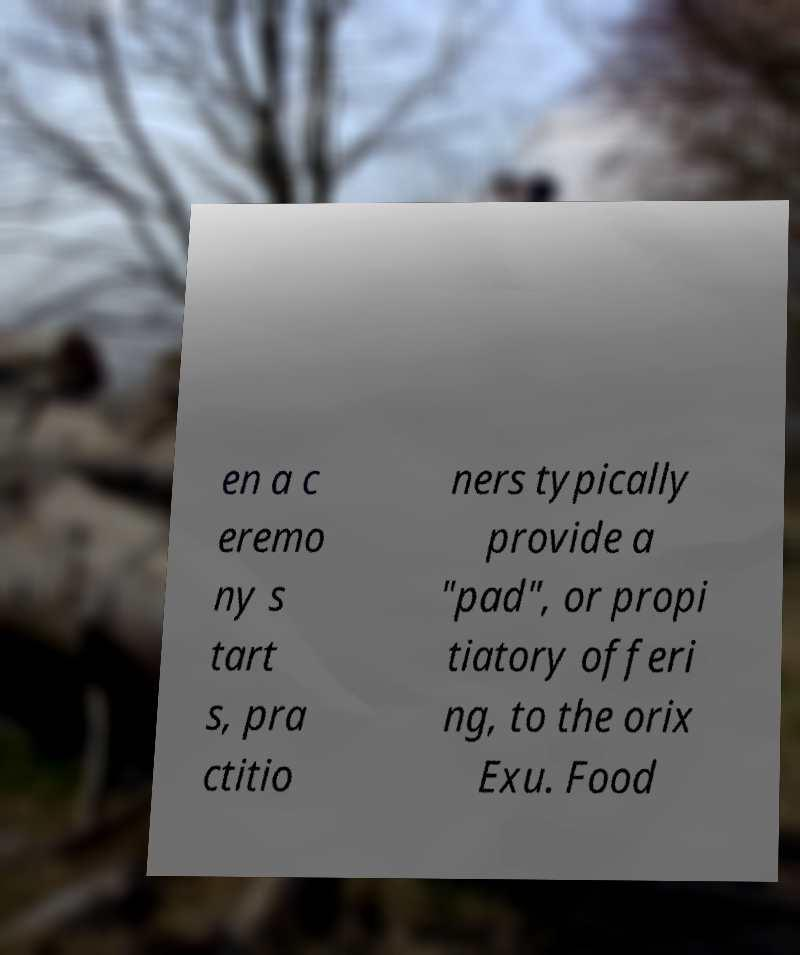Please read and relay the text visible in this image. What does it say? en a c eremo ny s tart s, pra ctitio ners typically provide a "pad", or propi tiatory offeri ng, to the orix Exu. Food 